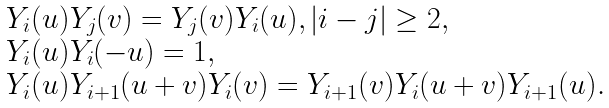Convert formula to latex. <formula><loc_0><loc_0><loc_500><loc_500>\begin{array} { l } Y _ { i } ( u ) Y _ { j } ( v ) = Y _ { j } ( v ) Y _ { i } ( u ) , | i - j | \geq 2 , \\ Y _ { i } ( u ) Y _ { i } ( - u ) = 1 , \\ Y _ { i } ( u ) Y _ { i + 1 } ( u + v ) Y _ { i } ( v ) = Y _ { i + 1 } ( v ) Y _ { i } ( u + v ) Y _ { i + 1 } ( u ) . \end{array}</formula> 